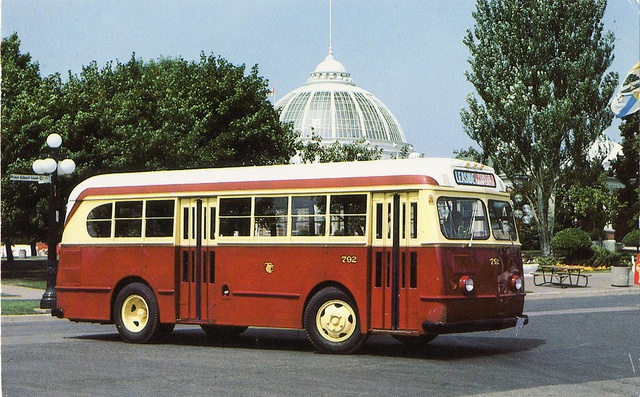Describe the objects in this image and their specific colors. I can see bus in white, black, brown, ivory, and maroon tones, bench in white, darkgray, black, gray, and tan tones, and people in white, gray, black, and purple tones in this image. 